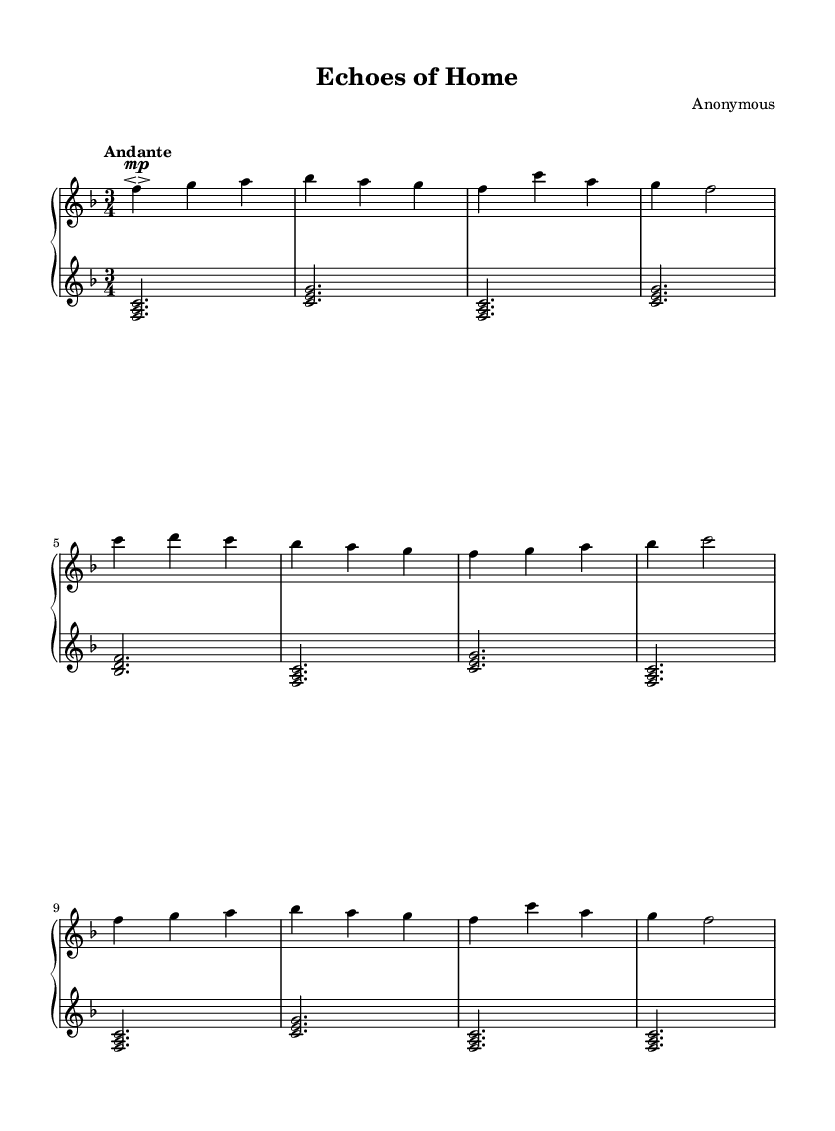What is the key signature of this music? The key signature is F major, which has one flat (B flat).
Answer: F major What is the time signature of this music? The time signature is 3/4, indicating three beats per measure.
Answer: 3/4 What is the tempo indication for this piece? The tempo indication is "Andante," suggesting a moderately slow pace.
Answer: Andante How many measures are in the A section of the piece? The A section consists of four measures, as seen before the B section starts.
Answer: Four What dynamic indication is marked for the upper staff? The dynamic indication is marked "mp," which stands for mezzo-piano, meaning moderately soft.
Answer: mp Which chord is played in the first measure of the lower staff? The first measure of the lower staff contains the chord F, A, C.
Answer: F A C Explain the structure of the piece based on its sections. The piece is structured in a ternary form: A section is repeated as A', and includes a contrasting B section, illustrating a simple ABA' format. Each section evokes themes of home and family through melody.
Answer: ABA' 